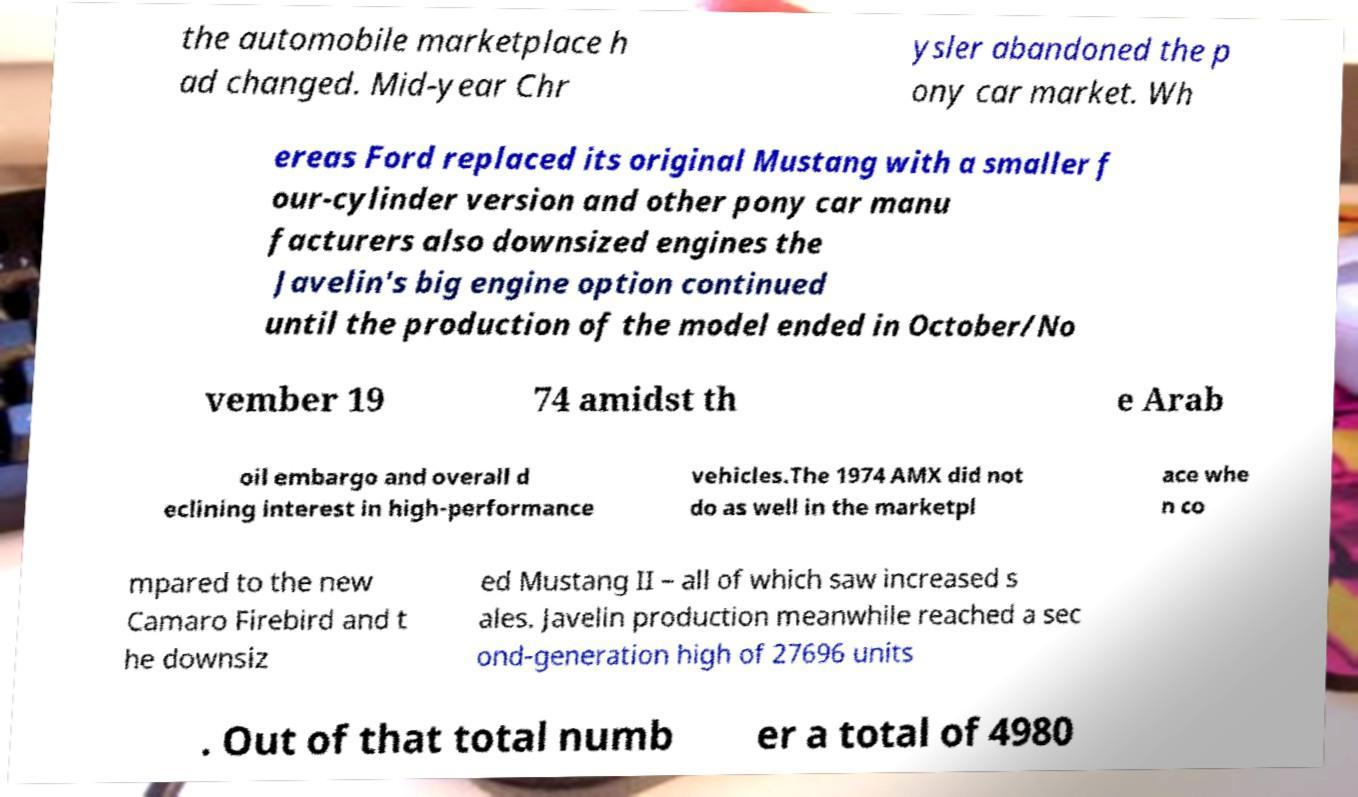Please identify and transcribe the text found in this image. the automobile marketplace h ad changed. Mid-year Chr ysler abandoned the p ony car market. Wh ereas Ford replaced its original Mustang with a smaller f our-cylinder version and other pony car manu facturers also downsized engines the Javelin's big engine option continued until the production of the model ended in October/No vember 19 74 amidst th e Arab oil embargo and overall d eclining interest in high-performance vehicles.The 1974 AMX did not do as well in the marketpl ace whe n co mpared to the new Camaro Firebird and t he downsiz ed Mustang II – all of which saw increased s ales. Javelin production meanwhile reached a sec ond-generation high of 27696 units . Out of that total numb er a total of 4980 